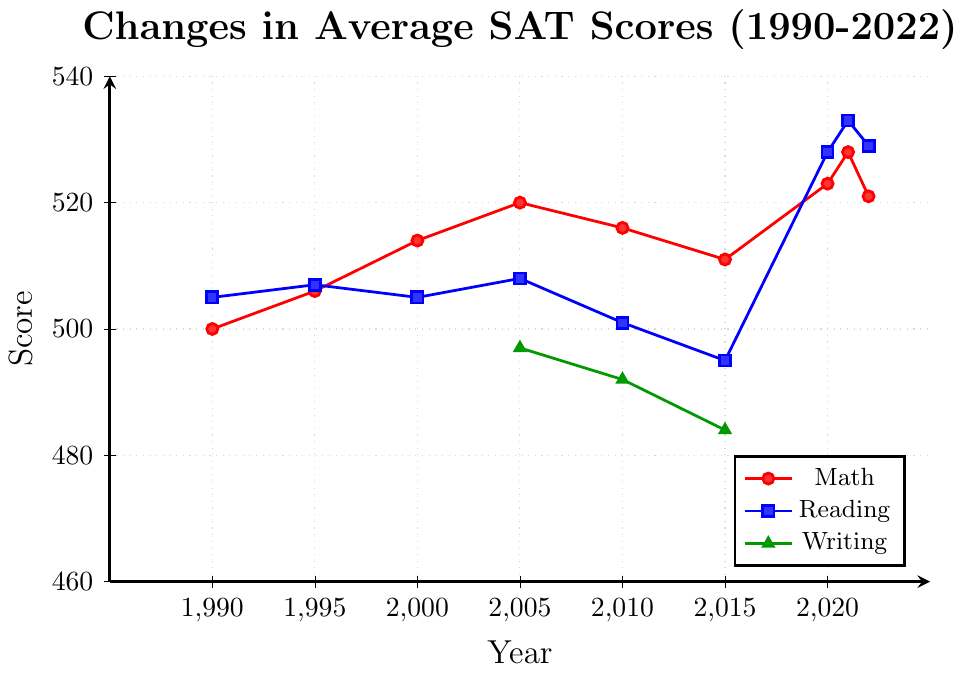What's the trend in Math scores from 2010 to 2021? Observing the Math line (red), we see that the score increases from 516 in 2010 to 528 in 2021.
Answer: Upward trend Which subject had the highest overall score in 2021? The 2021 scores are 528 for Math (red), 533 for Reading (blue), and Writing is not available. The highest score is for Reading.
Answer: Reading Between 1990 and 2022, in which years did Math scores decrease? Observing the Math line (red), we notice it decreases between 2005 (520) and 2010 (516), and between 2021 (528) and 2022 (521).
Answer: 2005 to 2010, 2021 to 2022 What is the difference between Math and Reading scores in 2020? The 2020 Math score is 523, and the Reading score is 528. The difference is 528 - 523 = 5.
Answer: 5 Which subject showed the most improvement between their first and last recorded values, and how much? Math improved from 500 (1990) to 521 (2022), an increase of 21. Reading improved from 505 (1990) to 529 (2022), an increase of 24. Writing is not consistent and thus not counted.
Answer: Reading improved by 24 Looking at Writing scores, what is the average value from 2005 to 2015? Writing scores are 497 (2005), 492 (2010), and 484 (2015). The average is (497 + 492 + 484)/3 = 491.
Answer: 491 In which year did the largest drop occur for Reading scores, and what is that drop? Reading dropped from 507 (1995) to 505 (2000), a drop of 2 points. Later it dropped more significantly from 508 (2005) to 501 (2010), a drop of 7 points, which is the largest.
Answer: 2010, drop of 7 points Which subject's scores remained closest to each other over the recorded years? Math scores range from 500 to 528, while Reading scores range from 495 to 533, and Writing scores from 484 to 497. Math has the smallest score range (28 points).
Answer: Math What is the highest value recorded for any of the subjects, and in which year? The highest value recorded is for Reading in 2021, with a score of 533.
Answer: 533 in 2021 How do the Reading scores in 1990 compare to the Math scores in 1990? The Reading score in 1990 is 505, and the Math score in 1990 is 500. Reading scores are greater than Math by 5 points.
Answer: Reading scores are greater by 5 points 